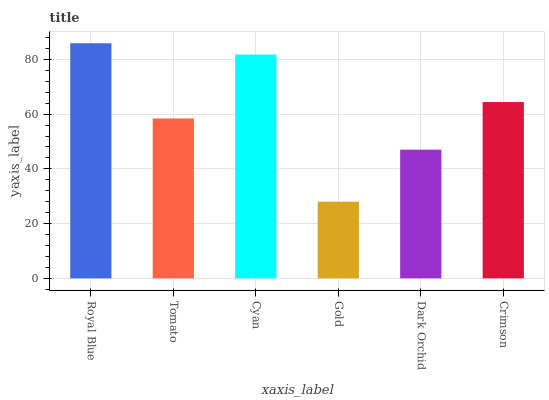Is Gold the minimum?
Answer yes or no. Yes. Is Royal Blue the maximum?
Answer yes or no. Yes. Is Tomato the minimum?
Answer yes or no. No. Is Tomato the maximum?
Answer yes or no. No. Is Royal Blue greater than Tomato?
Answer yes or no. Yes. Is Tomato less than Royal Blue?
Answer yes or no. Yes. Is Tomato greater than Royal Blue?
Answer yes or no. No. Is Royal Blue less than Tomato?
Answer yes or no. No. Is Crimson the high median?
Answer yes or no. Yes. Is Tomato the low median?
Answer yes or no. Yes. Is Cyan the high median?
Answer yes or no. No. Is Gold the low median?
Answer yes or no. No. 